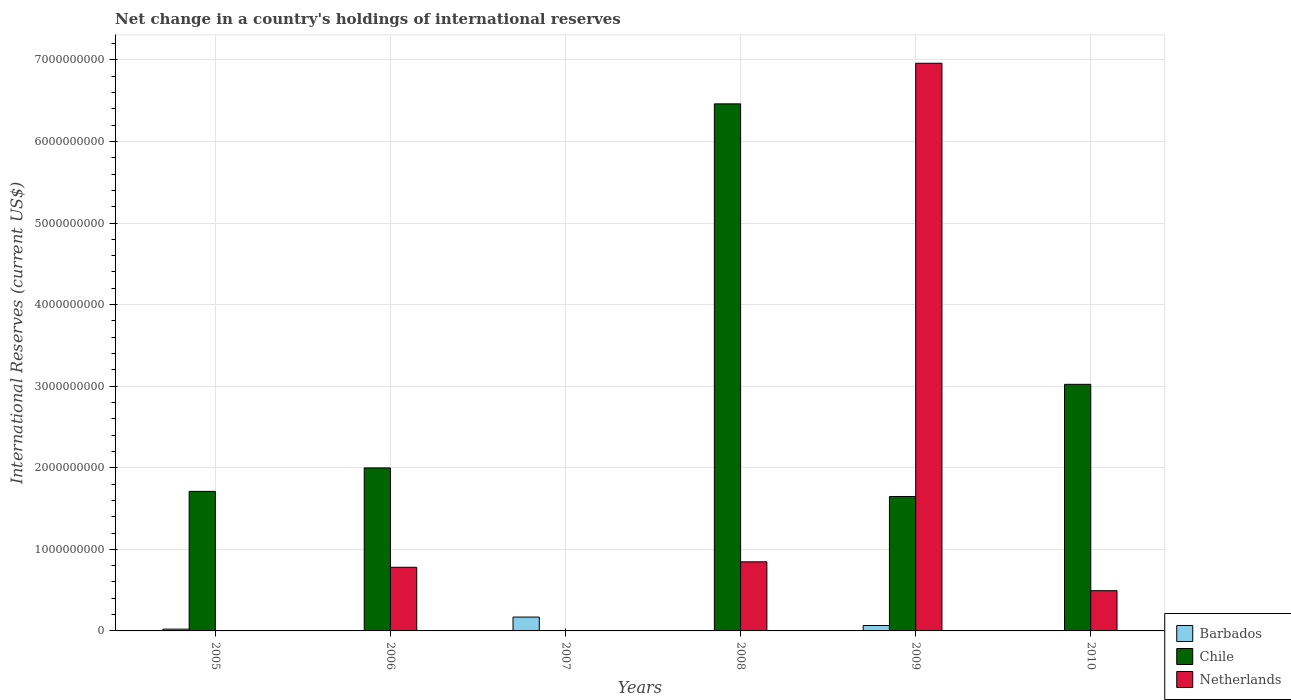How many bars are there on the 6th tick from the left?
Make the answer very short. 2. How many bars are there on the 3rd tick from the right?
Provide a succinct answer. 2. What is the label of the 4th group of bars from the left?
Keep it short and to the point. 2008. What is the international reserves in Barbados in 2006?
Make the answer very short. 0. Across all years, what is the maximum international reserves in Barbados?
Offer a very short reply. 1.70e+08. Across all years, what is the minimum international reserves in Barbados?
Your answer should be very brief. 0. In which year was the international reserves in Barbados maximum?
Offer a very short reply. 2007. What is the total international reserves in Chile in the graph?
Make the answer very short. 1.48e+1. What is the difference between the international reserves in Chile in 2008 and that in 2010?
Your answer should be very brief. 3.44e+09. What is the difference between the international reserves in Chile in 2008 and the international reserves in Barbados in 2006?
Provide a succinct answer. 6.46e+09. What is the average international reserves in Chile per year?
Offer a very short reply. 2.47e+09. In the year 2009, what is the difference between the international reserves in Netherlands and international reserves in Barbados?
Provide a succinct answer. 6.89e+09. In how many years, is the international reserves in Chile greater than 2600000000 US$?
Make the answer very short. 2. What is the ratio of the international reserves in Barbados in 2005 to that in 2009?
Offer a very short reply. 0.33. Is the international reserves in Netherlands in 2006 less than that in 2010?
Offer a terse response. No. What is the difference between the highest and the second highest international reserves in Barbados?
Ensure brevity in your answer.  1.03e+08. What is the difference between the highest and the lowest international reserves in Netherlands?
Provide a succinct answer. 6.96e+09. How many years are there in the graph?
Your response must be concise. 6. What is the difference between two consecutive major ticks on the Y-axis?
Give a very brief answer. 1.00e+09. Are the values on the major ticks of Y-axis written in scientific E-notation?
Give a very brief answer. No. Does the graph contain any zero values?
Your answer should be very brief. Yes. Where does the legend appear in the graph?
Offer a very short reply. Bottom right. How many legend labels are there?
Ensure brevity in your answer.  3. How are the legend labels stacked?
Offer a very short reply. Vertical. What is the title of the graph?
Give a very brief answer. Net change in a country's holdings of international reserves. Does "Gabon" appear as one of the legend labels in the graph?
Keep it short and to the point. No. What is the label or title of the Y-axis?
Ensure brevity in your answer.  International Reserves (current US$). What is the International Reserves (current US$) of Barbados in 2005?
Your answer should be very brief. 2.19e+07. What is the International Reserves (current US$) in Chile in 2005?
Provide a succinct answer. 1.71e+09. What is the International Reserves (current US$) of Chile in 2006?
Your answer should be compact. 2.00e+09. What is the International Reserves (current US$) in Netherlands in 2006?
Your answer should be compact. 7.80e+08. What is the International Reserves (current US$) in Barbados in 2007?
Your response must be concise. 1.70e+08. What is the International Reserves (current US$) of Barbados in 2008?
Make the answer very short. 0. What is the International Reserves (current US$) in Chile in 2008?
Provide a short and direct response. 6.46e+09. What is the International Reserves (current US$) in Netherlands in 2008?
Offer a terse response. 8.47e+08. What is the International Reserves (current US$) of Barbados in 2009?
Your answer should be very brief. 6.65e+07. What is the International Reserves (current US$) in Chile in 2009?
Your answer should be compact. 1.65e+09. What is the International Reserves (current US$) in Netherlands in 2009?
Your answer should be very brief. 6.96e+09. What is the International Reserves (current US$) of Chile in 2010?
Provide a short and direct response. 3.02e+09. What is the International Reserves (current US$) of Netherlands in 2010?
Ensure brevity in your answer.  4.93e+08. Across all years, what is the maximum International Reserves (current US$) of Barbados?
Ensure brevity in your answer.  1.70e+08. Across all years, what is the maximum International Reserves (current US$) in Chile?
Ensure brevity in your answer.  6.46e+09. Across all years, what is the maximum International Reserves (current US$) of Netherlands?
Provide a short and direct response. 6.96e+09. Across all years, what is the minimum International Reserves (current US$) in Barbados?
Provide a short and direct response. 0. Across all years, what is the minimum International Reserves (current US$) of Chile?
Make the answer very short. 0. Across all years, what is the minimum International Reserves (current US$) in Netherlands?
Your answer should be very brief. 0. What is the total International Reserves (current US$) of Barbados in the graph?
Provide a succinct answer. 2.58e+08. What is the total International Reserves (current US$) in Chile in the graph?
Keep it short and to the point. 1.48e+1. What is the total International Reserves (current US$) of Netherlands in the graph?
Keep it short and to the point. 9.08e+09. What is the difference between the International Reserves (current US$) of Chile in 2005 and that in 2006?
Provide a short and direct response. -2.88e+08. What is the difference between the International Reserves (current US$) of Barbados in 2005 and that in 2007?
Provide a succinct answer. -1.48e+08. What is the difference between the International Reserves (current US$) in Chile in 2005 and that in 2008?
Provide a short and direct response. -4.75e+09. What is the difference between the International Reserves (current US$) in Barbados in 2005 and that in 2009?
Your answer should be compact. -4.46e+07. What is the difference between the International Reserves (current US$) in Chile in 2005 and that in 2009?
Offer a very short reply. 6.30e+07. What is the difference between the International Reserves (current US$) of Chile in 2005 and that in 2010?
Keep it short and to the point. -1.31e+09. What is the difference between the International Reserves (current US$) of Chile in 2006 and that in 2008?
Your answer should be very brief. -4.46e+09. What is the difference between the International Reserves (current US$) in Netherlands in 2006 and that in 2008?
Give a very brief answer. -6.68e+07. What is the difference between the International Reserves (current US$) in Chile in 2006 and that in 2009?
Keep it short and to the point. 3.50e+08. What is the difference between the International Reserves (current US$) of Netherlands in 2006 and that in 2009?
Your answer should be very brief. -6.18e+09. What is the difference between the International Reserves (current US$) of Chile in 2006 and that in 2010?
Give a very brief answer. -1.02e+09. What is the difference between the International Reserves (current US$) of Netherlands in 2006 and that in 2010?
Your response must be concise. 2.87e+08. What is the difference between the International Reserves (current US$) in Barbados in 2007 and that in 2009?
Provide a short and direct response. 1.03e+08. What is the difference between the International Reserves (current US$) of Chile in 2008 and that in 2009?
Provide a short and direct response. 4.81e+09. What is the difference between the International Reserves (current US$) of Netherlands in 2008 and that in 2009?
Make the answer very short. -6.11e+09. What is the difference between the International Reserves (current US$) of Chile in 2008 and that in 2010?
Offer a terse response. 3.44e+09. What is the difference between the International Reserves (current US$) of Netherlands in 2008 and that in 2010?
Ensure brevity in your answer.  3.54e+08. What is the difference between the International Reserves (current US$) in Chile in 2009 and that in 2010?
Your response must be concise. -1.38e+09. What is the difference between the International Reserves (current US$) of Netherlands in 2009 and that in 2010?
Ensure brevity in your answer.  6.47e+09. What is the difference between the International Reserves (current US$) of Barbados in 2005 and the International Reserves (current US$) of Chile in 2006?
Give a very brief answer. -1.98e+09. What is the difference between the International Reserves (current US$) of Barbados in 2005 and the International Reserves (current US$) of Netherlands in 2006?
Offer a terse response. -7.58e+08. What is the difference between the International Reserves (current US$) of Chile in 2005 and the International Reserves (current US$) of Netherlands in 2006?
Offer a terse response. 9.31e+08. What is the difference between the International Reserves (current US$) in Barbados in 2005 and the International Reserves (current US$) in Chile in 2008?
Give a very brief answer. -6.44e+09. What is the difference between the International Reserves (current US$) of Barbados in 2005 and the International Reserves (current US$) of Netherlands in 2008?
Provide a succinct answer. -8.25e+08. What is the difference between the International Reserves (current US$) of Chile in 2005 and the International Reserves (current US$) of Netherlands in 2008?
Offer a terse response. 8.64e+08. What is the difference between the International Reserves (current US$) of Barbados in 2005 and the International Reserves (current US$) of Chile in 2009?
Provide a short and direct response. -1.63e+09. What is the difference between the International Reserves (current US$) of Barbados in 2005 and the International Reserves (current US$) of Netherlands in 2009?
Ensure brevity in your answer.  -6.94e+09. What is the difference between the International Reserves (current US$) of Chile in 2005 and the International Reserves (current US$) of Netherlands in 2009?
Provide a short and direct response. -5.25e+09. What is the difference between the International Reserves (current US$) in Barbados in 2005 and the International Reserves (current US$) in Chile in 2010?
Make the answer very short. -3.00e+09. What is the difference between the International Reserves (current US$) in Barbados in 2005 and the International Reserves (current US$) in Netherlands in 2010?
Your answer should be very brief. -4.71e+08. What is the difference between the International Reserves (current US$) in Chile in 2005 and the International Reserves (current US$) in Netherlands in 2010?
Provide a succinct answer. 1.22e+09. What is the difference between the International Reserves (current US$) of Chile in 2006 and the International Reserves (current US$) of Netherlands in 2008?
Your response must be concise. 1.15e+09. What is the difference between the International Reserves (current US$) in Chile in 2006 and the International Reserves (current US$) in Netherlands in 2009?
Offer a very short reply. -4.96e+09. What is the difference between the International Reserves (current US$) of Chile in 2006 and the International Reserves (current US$) of Netherlands in 2010?
Provide a succinct answer. 1.50e+09. What is the difference between the International Reserves (current US$) in Barbados in 2007 and the International Reserves (current US$) in Chile in 2008?
Your response must be concise. -6.29e+09. What is the difference between the International Reserves (current US$) of Barbados in 2007 and the International Reserves (current US$) of Netherlands in 2008?
Ensure brevity in your answer.  -6.77e+08. What is the difference between the International Reserves (current US$) in Barbados in 2007 and the International Reserves (current US$) in Chile in 2009?
Provide a succinct answer. -1.48e+09. What is the difference between the International Reserves (current US$) of Barbados in 2007 and the International Reserves (current US$) of Netherlands in 2009?
Provide a short and direct response. -6.79e+09. What is the difference between the International Reserves (current US$) in Barbados in 2007 and the International Reserves (current US$) in Chile in 2010?
Offer a terse response. -2.85e+09. What is the difference between the International Reserves (current US$) of Barbados in 2007 and the International Reserves (current US$) of Netherlands in 2010?
Ensure brevity in your answer.  -3.24e+08. What is the difference between the International Reserves (current US$) in Chile in 2008 and the International Reserves (current US$) in Netherlands in 2009?
Your answer should be very brief. -4.98e+08. What is the difference between the International Reserves (current US$) of Chile in 2008 and the International Reserves (current US$) of Netherlands in 2010?
Keep it short and to the point. 5.97e+09. What is the difference between the International Reserves (current US$) in Barbados in 2009 and the International Reserves (current US$) in Chile in 2010?
Your response must be concise. -2.96e+09. What is the difference between the International Reserves (current US$) of Barbados in 2009 and the International Reserves (current US$) of Netherlands in 2010?
Offer a terse response. -4.27e+08. What is the difference between the International Reserves (current US$) in Chile in 2009 and the International Reserves (current US$) in Netherlands in 2010?
Offer a very short reply. 1.15e+09. What is the average International Reserves (current US$) in Barbados per year?
Give a very brief answer. 4.30e+07. What is the average International Reserves (current US$) in Chile per year?
Your response must be concise. 2.47e+09. What is the average International Reserves (current US$) of Netherlands per year?
Your answer should be compact. 1.51e+09. In the year 2005, what is the difference between the International Reserves (current US$) of Barbados and International Reserves (current US$) of Chile?
Ensure brevity in your answer.  -1.69e+09. In the year 2006, what is the difference between the International Reserves (current US$) in Chile and International Reserves (current US$) in Netherlands?
Provide a succinct answer. 1.22e+09. In the year 2008, what is the difference between the International Reserves (current US$) in Chile and International Reserves (current US$) in Netherlands?
Provide a short and direct response. 5.61e+09. In the year 2009, what is the difference between the International Reserves (current US$) of Barbados and International Reserves (current US$) of Chile?
Your answer should be compact. -1.58e+09. In the year 2009, what is the difference between the International Reserves (current US$) in Barbados and International Reserves (current US$) in Netherlands?
Your answer should be compact. -6.89e+09. In the year 2009, what is the difference between the International Reserves (current US$) in Chile and International Reserves (current US$) in Netherlands?
Offer a terse response. -5.31e+09. In the year 2010, what is the difference between the International Reserves (current US$) of Chile and International Reserves (current US$) of Netherlands?
Your answer should be very brief. 2.53e+09. What is the ratio of the International Reserves (current US$) in Chile in 2005 to that in 2006?
Keep it short and to the point. 0.86. What is the ratio of the International Reserves (current US$) of Barbados in 2005 to that in 2007?
Give a very brief answer. 0.13. What is the ratio of the International Reserves (current US$) of Chile in 2005 to that in 2008?
Your response must be concise. 0.26. What is the ratio of the International Reserves (current US$) of Barbados in 2005 to that in 2009?
Make the answer very short. 0.33. What is the ratio of the International Reserves (current US$) of Chile in 2005 to that in 2009?
Your answer should be very brief. 1.04. What is the ratio of the International Reserves (current US$) in Chile in 2005 to that in 2010?
Your response must be concise. 0.57. What is the ratio of the International Reserves (current US$) in Chile in 2006 to that in 2008?
Offer a terse response. 0.31. What is the ratio of the International Reserves (current US$) in Netherlands in 2006 to that in 2008?
Provide a succinct answer. 0.92. What is the ratio of the International Reserves (current US$) of Chile in 2006 to that in 2009?
Offer a terse response. 1.21. What is the ratio of the International Reserves (current US$) of Netherlands in 2006 to that in 2009?
Ensure brevity in your answer.  0.11. What is the ratio of the International Reserves (current US$) in Chile in 2006 to that in 2010?
Ensure brevity in your answer.  0.66. What is the ratio of the International Reserves (current US$) in Netherlands in 2006 to that in 2010?
Ensure brevity in your answer.  1.58. What is the ratio of the International Reserves (current US$) of Barbados in 2007 to that in 2009?
Offer a terse response. 2.55. What is the ratio of the International Reserves (current US$) in Chile in 2008 to that in 2009?
Provide a short and direct response. 3.92. What is the ratio of the International Reserves (current US$) in Netherlands in 2008 to that in 2009?
Offer a very short reply. 0.12. What is the ratio of the International Reserves (current US$) of Chile in 2008 to that in 2010?
Offer a very short reply. 2.14. What is the ratio of the International Reserves (current US$) in Netherlands in 2008 to that in 2010?
Your answer should be compact. 1.72. What is the ratio of the International Reserves (current US$) of Chile in 2009 to that in 2010?
Your response must be concise. 0.55. What is the ratio of the International Reserves (current US$) of Netherlands in 2009 to that in 2010?
Provide a short and direct response. 14.1. What is the difference between the highest and the second highest International Reserves (current US$) in Barbados?
Ensure brevity in your answer.  1.03e+08. What is the difference between the highest and the second highest International Reserves (current US$) of Chile?
Offer a terse response. 3.44e+09. What is the difference between the highest and the second highest International Reserves (current US$) of Netherlands?
Your answer should be compact. 6.11e+09. What is the difference between the highest and the lowest International Reserves (current US$) of Barbados?
Offer a very short reply. 1.70e+08. What is the difference between the highest and the lowest International Reserves (current US$) of Chile?
Keep it short and to the point. 6.46e+09. What is the difference between the highest and the lowest International Reserves (current US$) of Netherlands?
Offer a very short reply. 6.96e+09. 